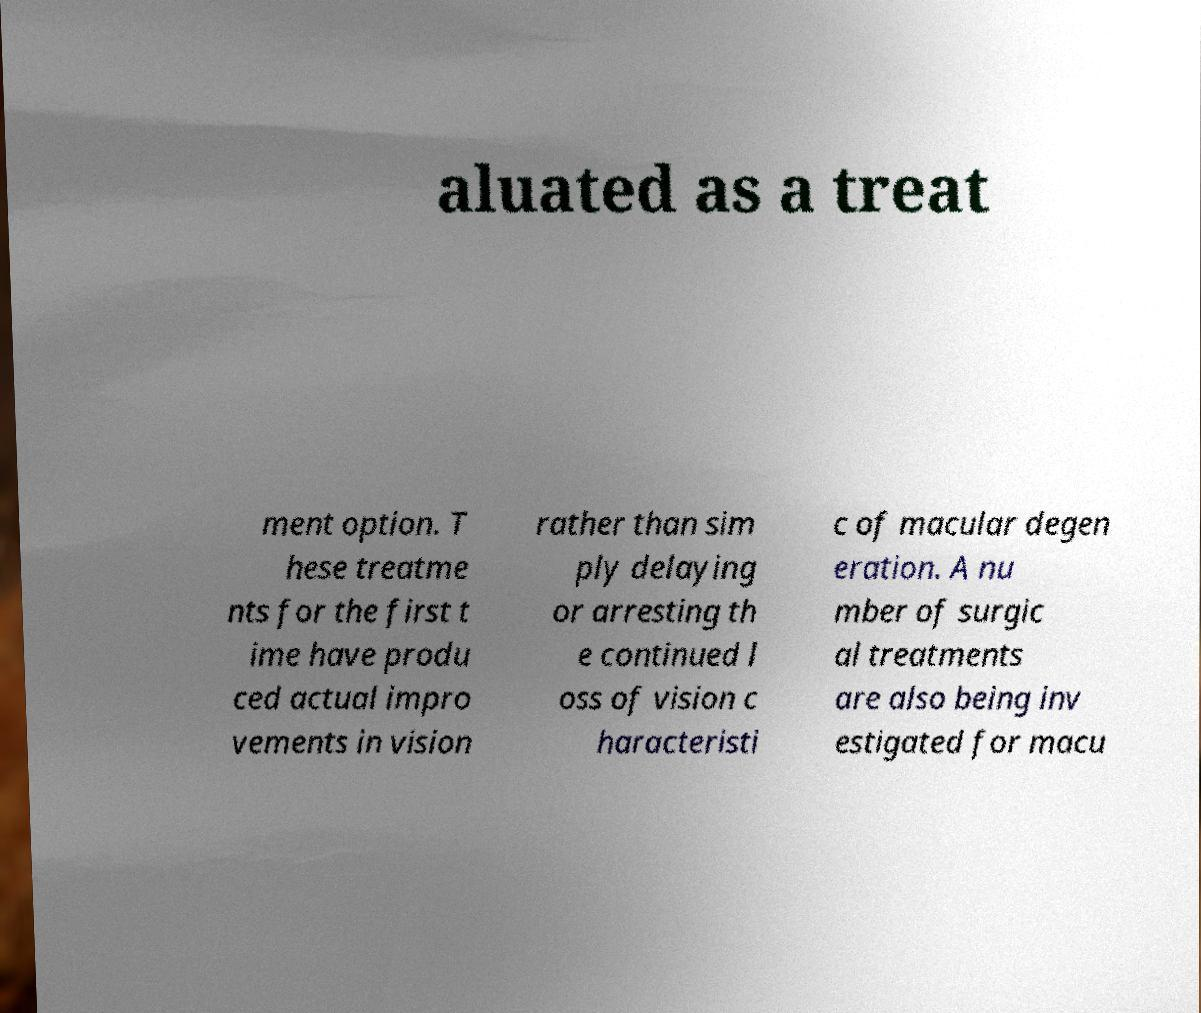What messages or text are displayed in this image? I need them in a readable, typed format. aluated as a treat ment option. T hese treatme nts for the first t ime have produ ced actual impro vements in vision rather than sim ply delaying or arresting th e continued l oss of vision c haracteristi c of macular degen eration. A nu mber of surgic al treatments are also being inv estigated for macu 